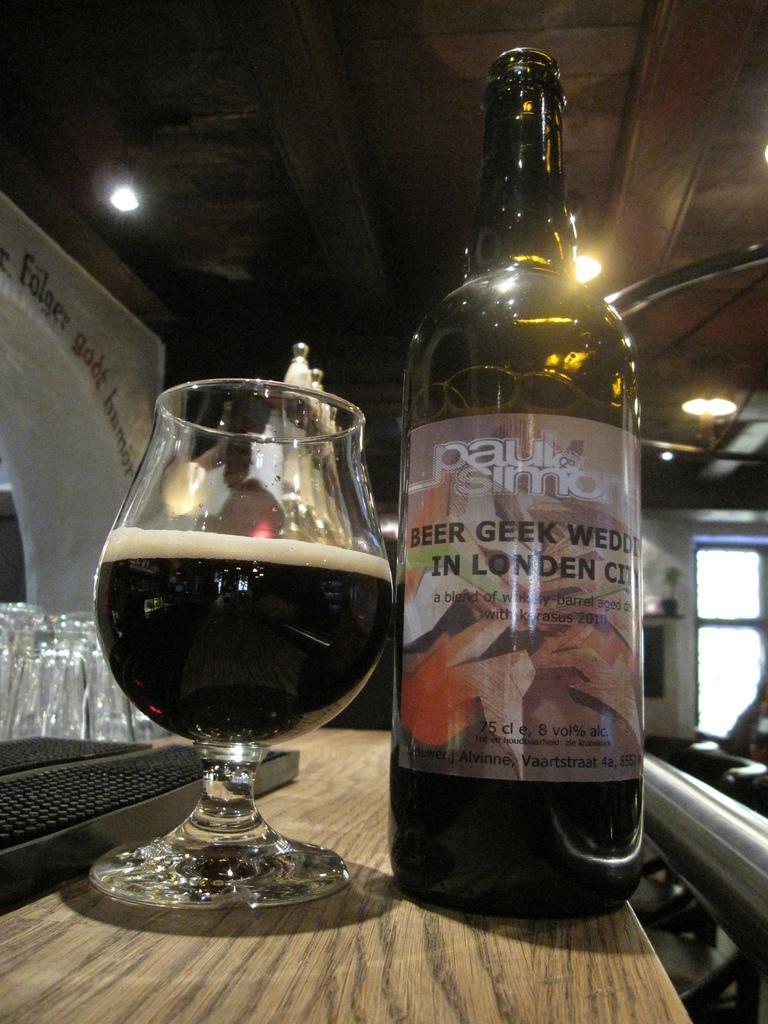Can you describe this image briefly? In this image In the middle there is a table on that there is a bottle and glass with drink in it. In the background there is a window, light, text and wall. 